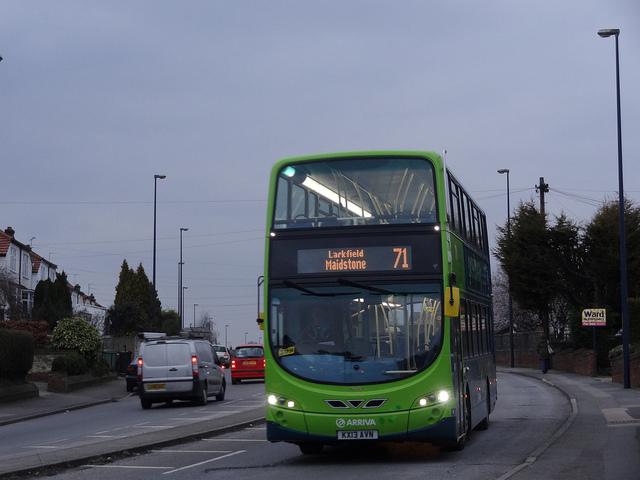Where is the bus going?
Keep it brief. Maidstone. What number of stories is this green bus?
Write a very short answer. 2. Is the bus in motion?
Keep it brief. Yes. 